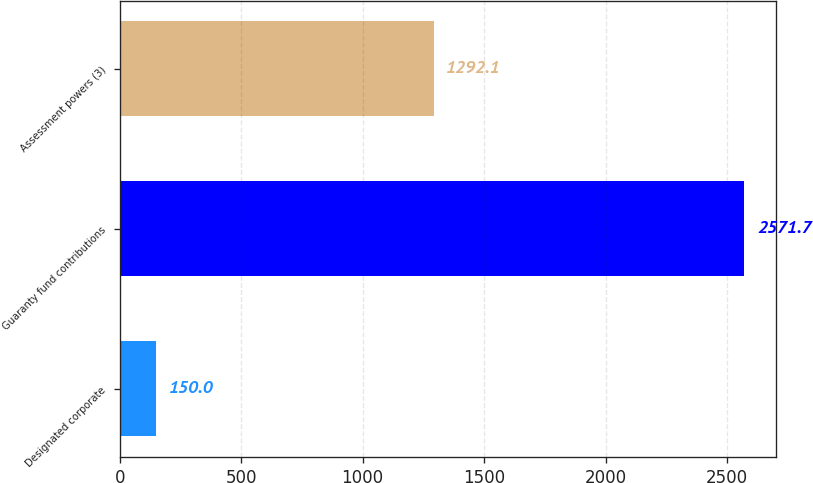Convert chart. <chart><loc_0><loc_0><loc_500><loc_500><bar_chart><fcel>Designated corporate<fcel>Guaranty fund contributions<fcel>Assessment powers (3)<nl><fcel>150<fcel>2571.7<fcel>1292.1<nl></chart> 